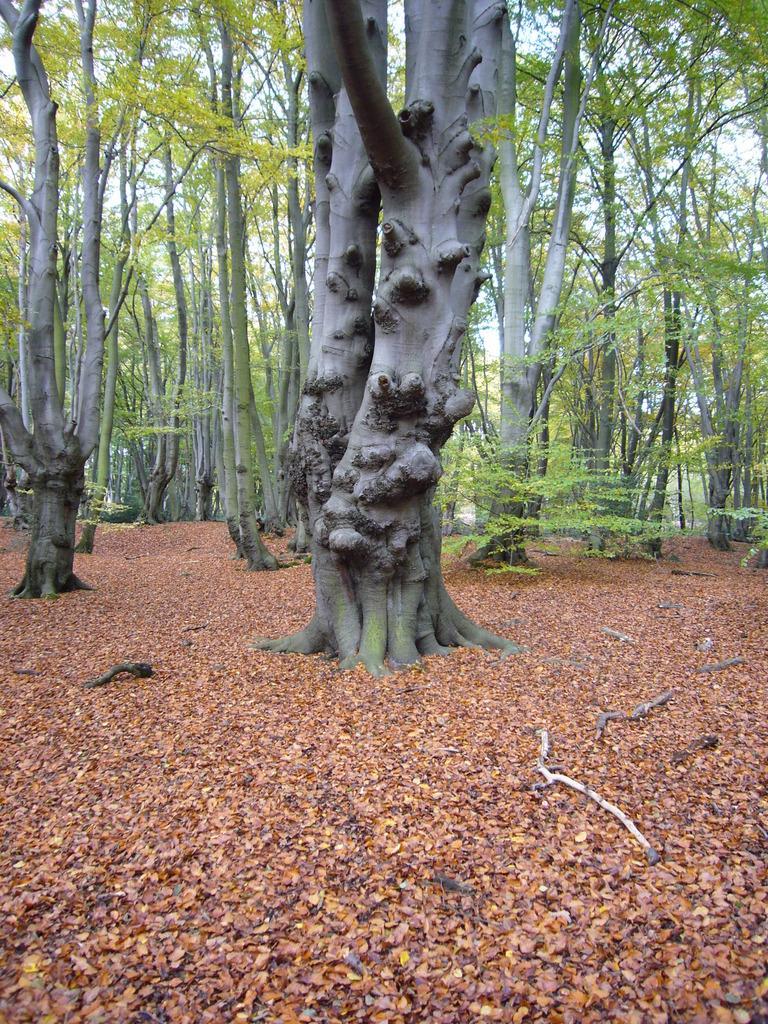How would you summarize this image in a sentence or two? In this picture I can see the ground in front, on which there are number of leaves and few sticks and in the background I can see number of trees. 